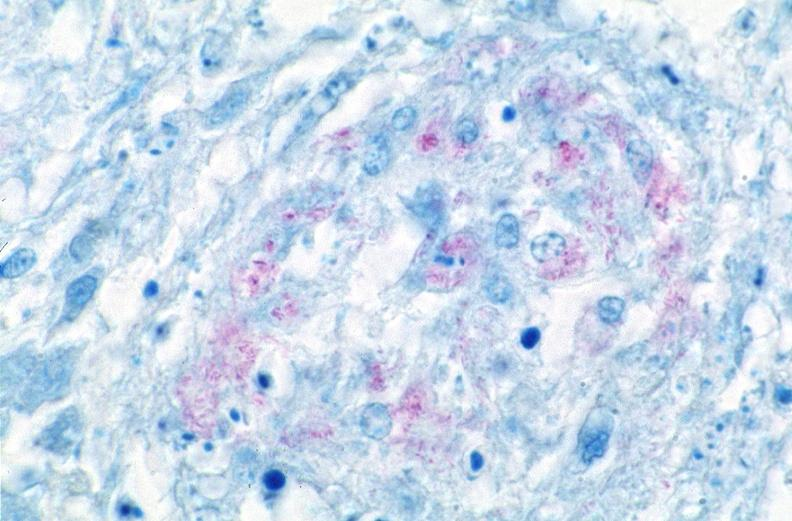s respiratory present?
Answer the question using a single word or phrase. Yes 